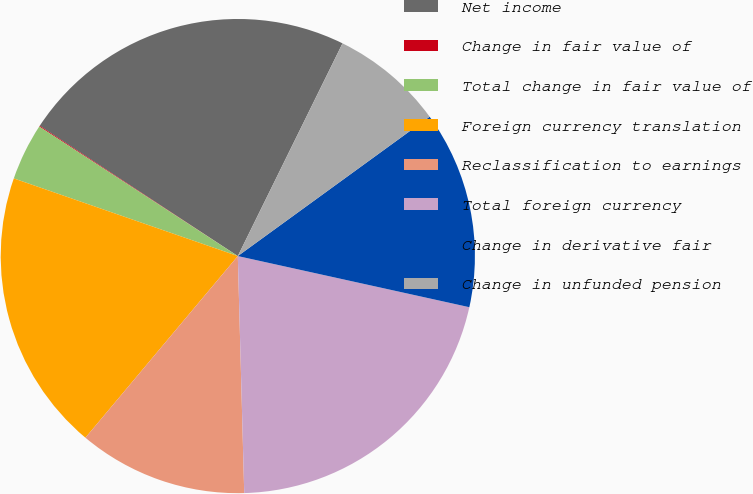<chart> <loc_0><loc_0><loc_500><loc_500><pie_chart><fcel>Net income<fcel>Change in fair value of<fcel>Total change in fair value of<fcel>Foreign currency translation<fcel>Reclassification to earnings<fcel>Total foreign currency<fcel>Change in derivative fair<fcel>Change in unfunded pension<nl><fcel>23.02%<fcel>0.06%<fcel>3.89%<fcel>19.2%<fcel>11.54%<fcel>21.11%<fcel>13.46%<fcel>7.72%<nl></chart> 